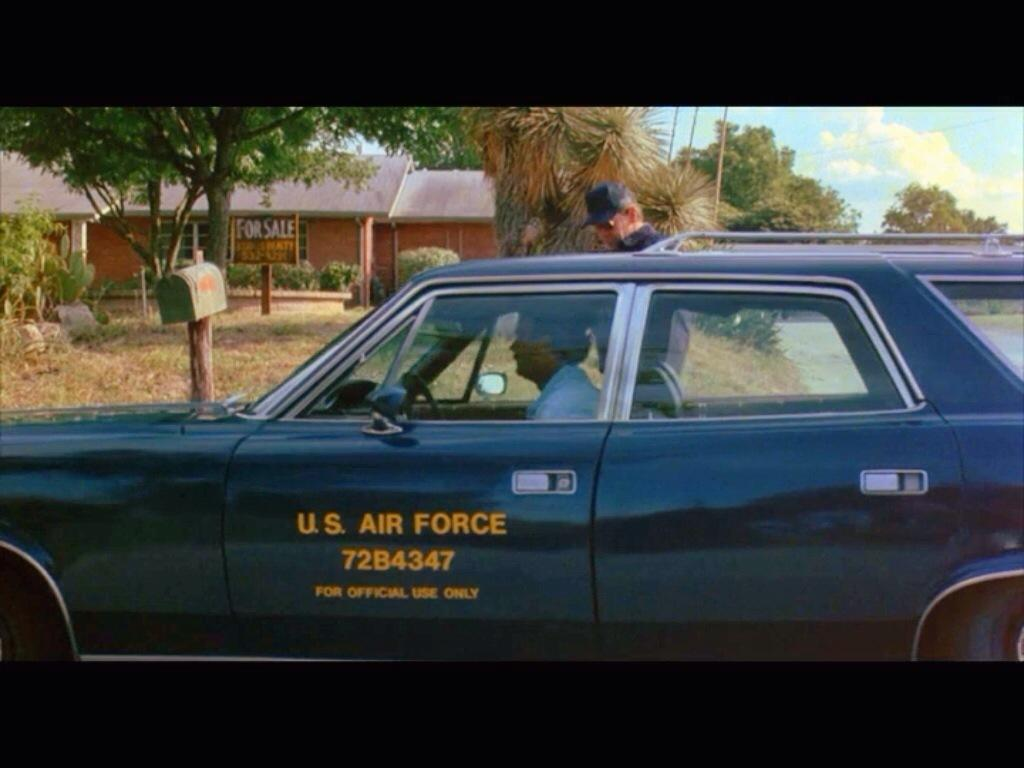What is the main subject of the image? There is a person driving a car in the image. What type of environment is visible in the image? There is grass, trees, and a building visible in the image. What is the condition of the sky in the image? The sky is clear in the image. What color is the rose on the person's lap in the image? There is no rose present in the image. What type of vest is the person wearing in the image? There is no vest visible in the image. 